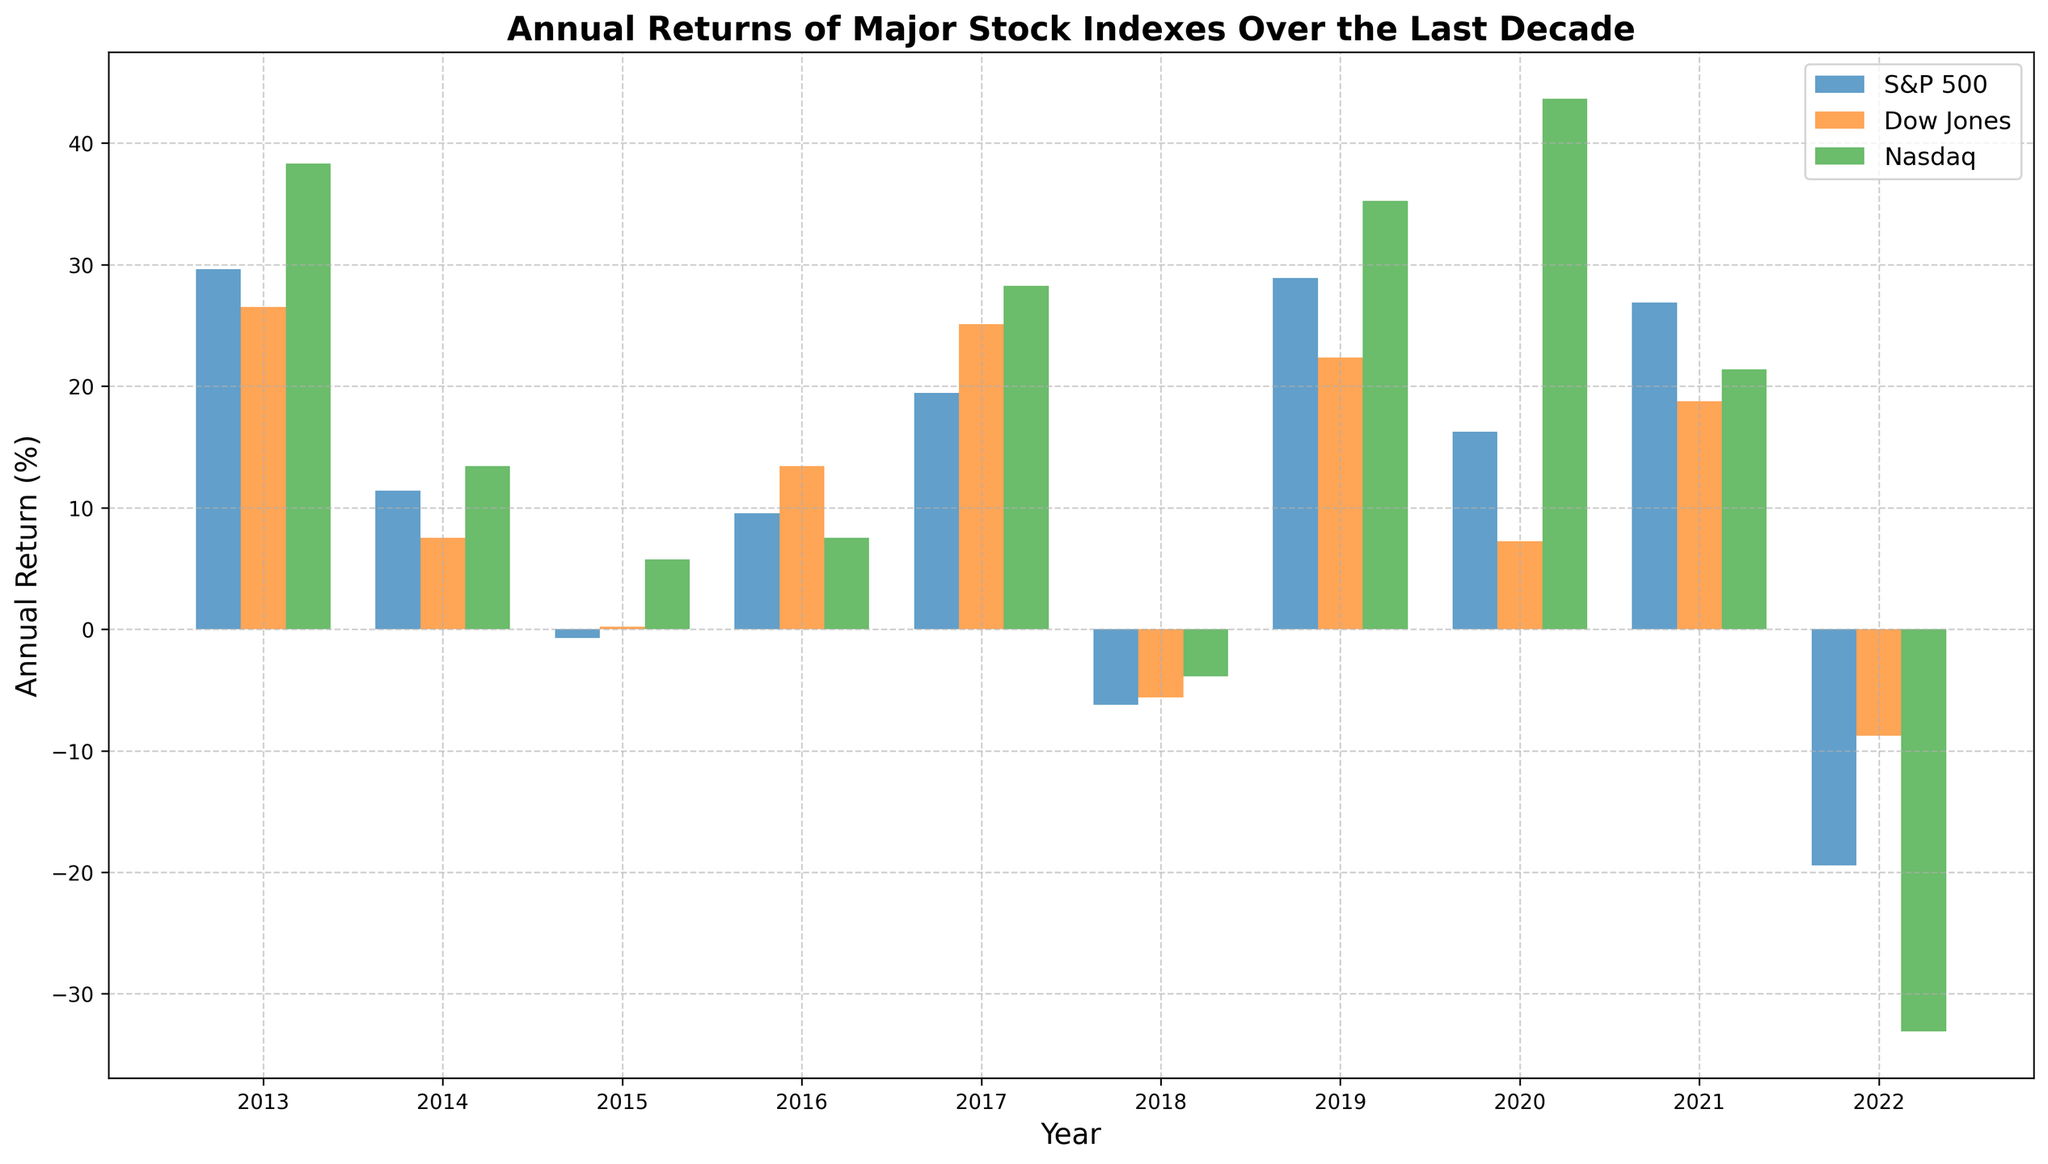What's the annual return of the S&P 500 in 2018? Look at the bar corresponding to 2018 for the S&P 500 in the figure and read off the value.
Answer: -6.24% How did the Nasdaq's performance in 2020 compare to its performance in 2022? Identify the bars for the Nasdaq in 2020 and 2022. The height of the bar for 2020 is much higher (positive return), while the bar for 2022 is lower (negative return).
Answer: The Nasdaq performed much better in 2020 than in 2022 Which index had the highest annual return in the decade, and in which year? Look for the tallest bar across all years and indexes. The tallest bar represents the highest return, which is for the Nasdaq in 2020.
Answer: Nasdaq, 2020 Did the Dow Jones have any years with a negative return? If so, which ones? Identify the bars for the Dow Jones and check if any are below the x-axis (indicating negative returns). The years with negative bars are 2018 and 2022.
Answer: Yes, 2018 and 2022 Calculate the average annual return of the S&P 500 over the last decade. Sum all annual returns for the S&P 500 and divide by the number of years (10): (29.60 + 11.39 - 0.73 + 9.54 + 19.42 - 6.24 + 28.88 + 16.26 + 26.89 - 19.44) / 10.
Answer: 11.86% Which year had the lowest overall return across the three indexes? Compare the bars for the lowest points across all years and indexes. The lowest bar is for the Nasdaq in 2022 (-33.10%).
Answer: 2022 Compare the performances of the Dow Jones and Nasdaq in 2019. Which performed better? Identify the bars for 2019 for both Dow Jones and Nasdaq. The bar for the Nasdaq is higher, indicating a better performance.
Answer: Nasdaq What is the range of annual returns for the Dow Jones? (Range is the difference between highest and lowest values) Identify the maximum and minimum values for the Dow Jones from the figure: 2017 (25.08) and 2022 (-8.78). Calculate the difference: 25.08 - (-8.78) = 33.86.
Answer: 33.86 Did the S&P 500 ever have consecutive years with negative returns? Identify the bars below the x-axis for S&P 500 and check if there are any consecutive years with negative returns: 2015 and 2018 are both negative but not consecutive.
Answer: No What was the combined annual return of all three indexes in 2017? Sum the annual returns for all three indexes in 2017: S&P 500 (19.42), Dow Jones (25.08), and Nasdaq (28.24). The combined return is 19.42 + 25.08 + 28.24 = 72.74.
Answer: 72.74 